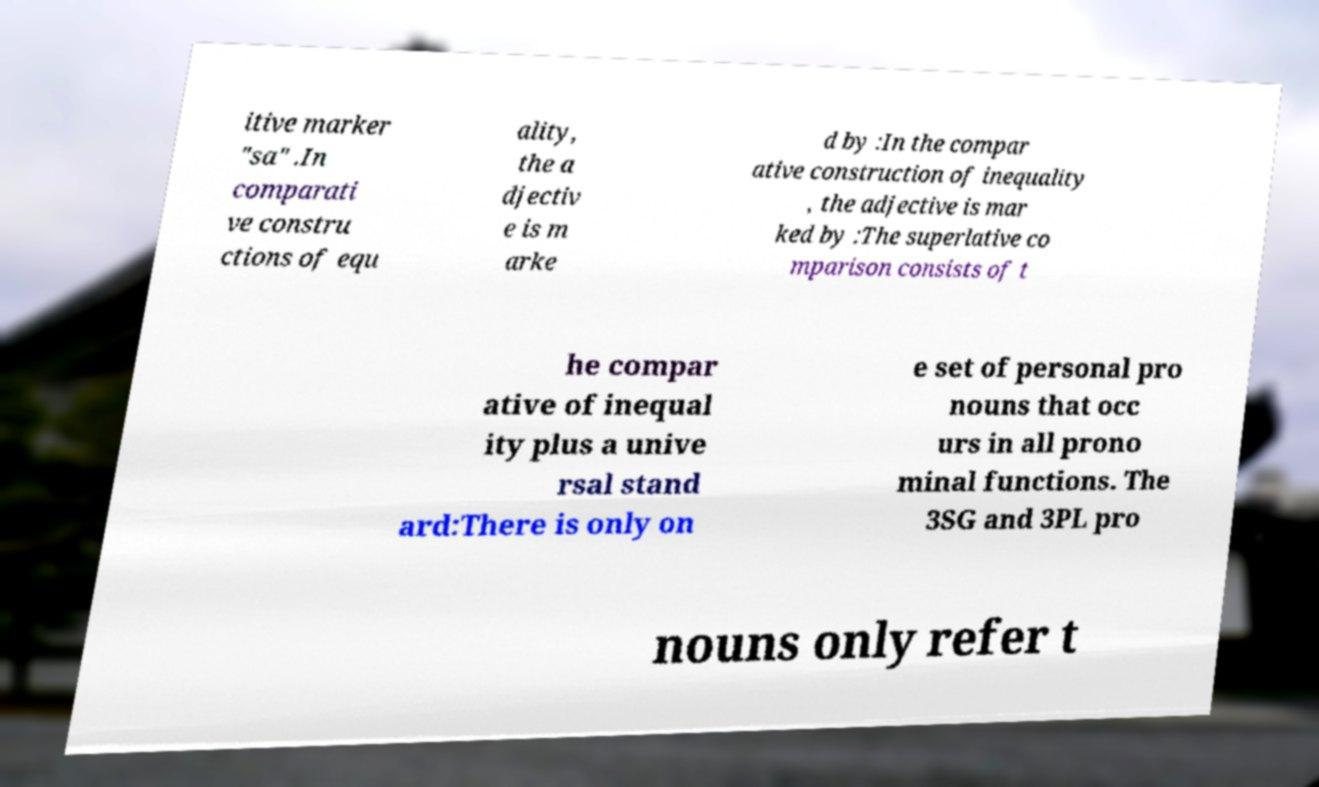There's text embedded in this image that I need extracted. Can you transcribe it verbatim? itive marker "sa" .In comparati ve constru ctions of equ ality, the a djectiv e is m arke d by :In the compar ative construction of inequality , the adjective is mar ked by :The superlative co mparison consists of t he compar ative of inequal ity plus a unive rsal stand ard:There is only on e set of personal pro nouns that occ urs in all prono minal functions. The 3SG and 3PL pro nouns only refer t 